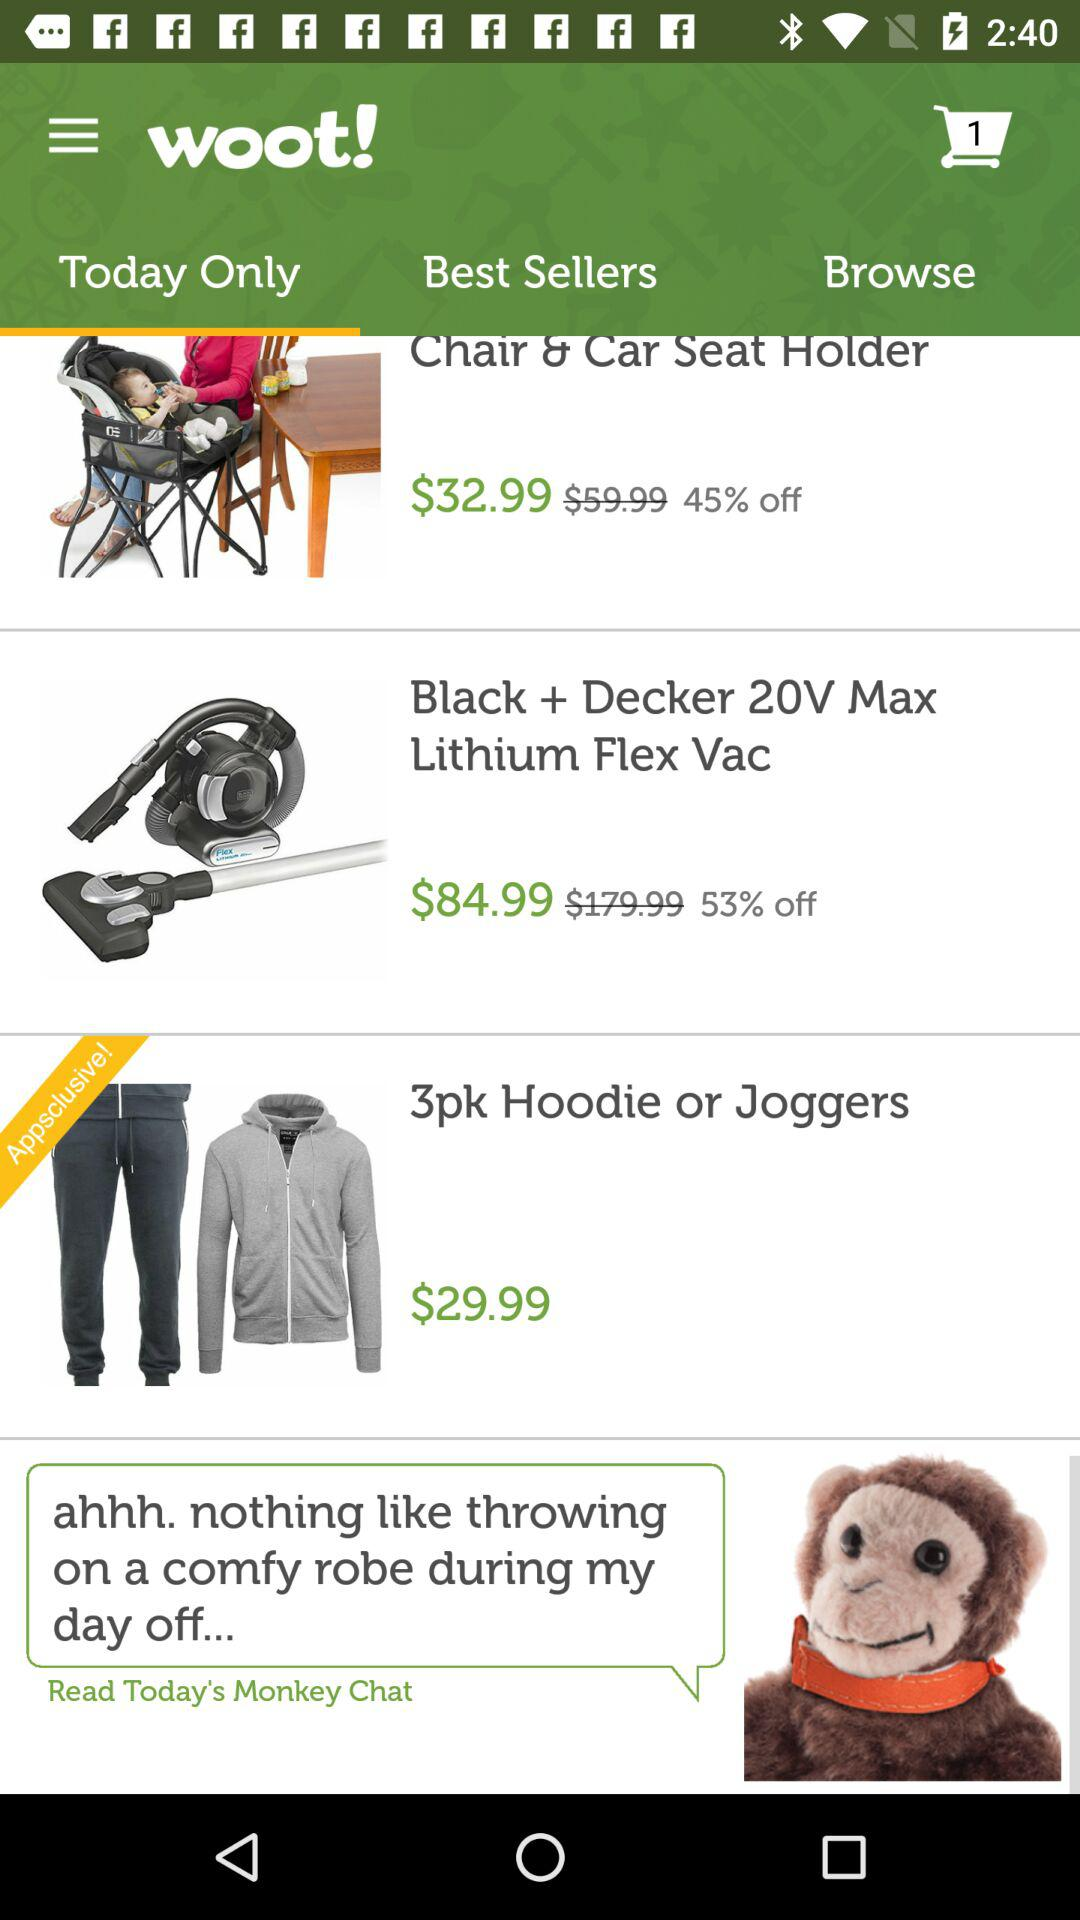Which tab is selected? The selected tab is "Today Only". 